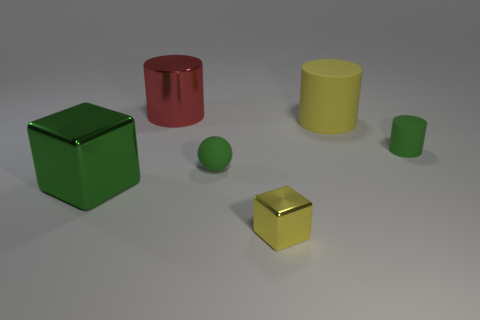What can you infer about the lighting and shadows in this image? The lighting in the image appears to be coming from the top left, given the direction of the shadows cast on the right side of the objects. All shadows are soft and diffused, suggesting the light source is not extremely close or intense. The lack of harsh shadows indicates the environment likely has ambient lighting, which contributes to the even illumination of the scene. 